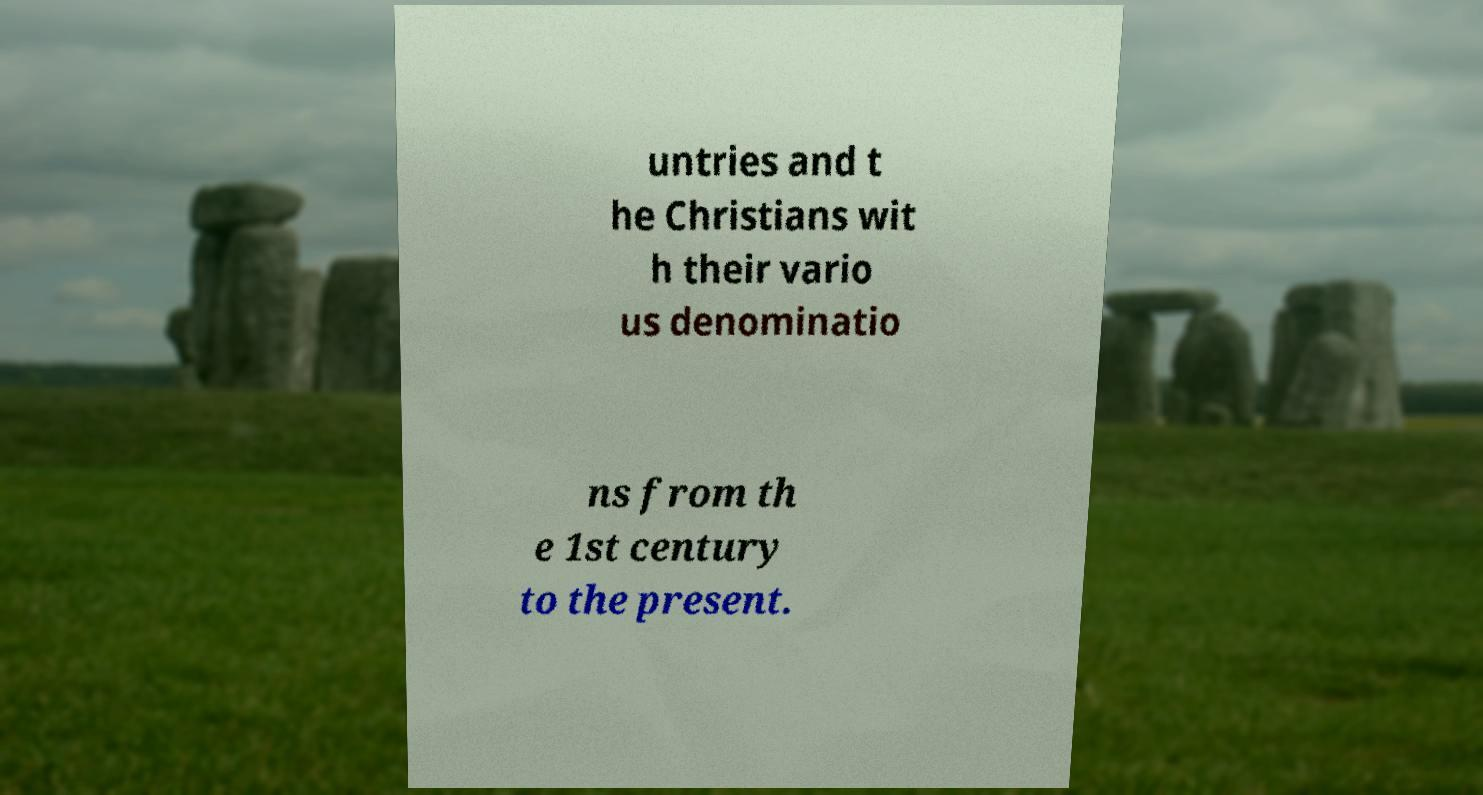Please identify and transcribe the text found in this image. untries and t he Christians wit h their vario us denominatio ns from th e 1st century to the present. 